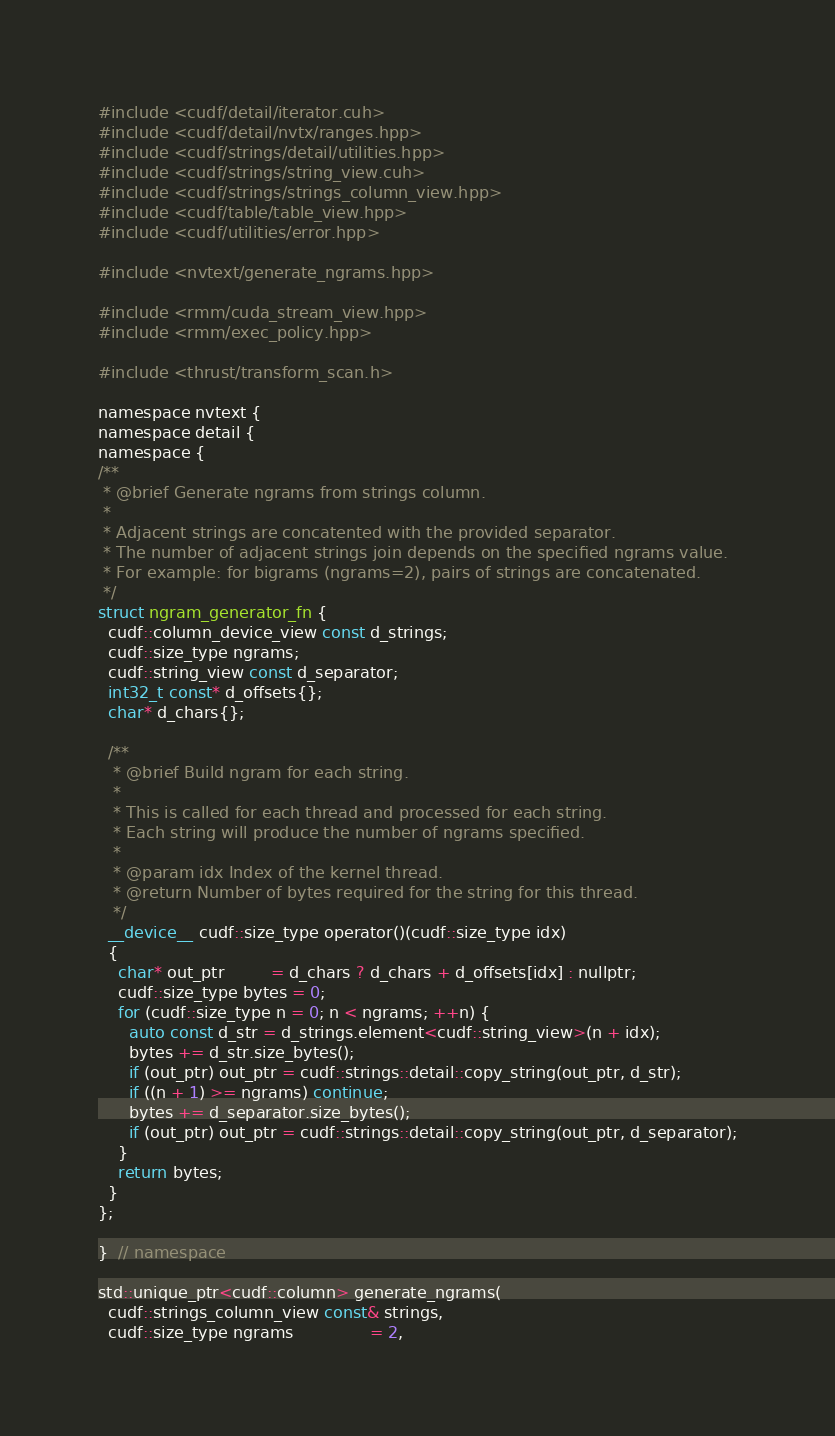<code> <loc_0><loc_0><loc_500><loc_500><_Cuda_>#include <cudf/detail/iterator.cuh>
#include <cudf/detail/nvtx/ranges.hpp>
#include <cudf/strings/detail/utilities.hpp>
#include <cudf/strings/string_view.cuh>
#include <cudf/strings/strings_column_view.hpp>
#include <cudf/table/table_view.hpp>
#include <cudf/utilities/error.hpp>

#include <nvtext/generate_ngrams.hpp>

#include <rmm/cuda_stream_view.hpp>
#include <rmm/exec_policy.hpp>

#include <thrust/transform_scan.h>

namespace nvtext {
namespace detail {
namespace {
/**
 * @brief Generate ngrams from strings column.
 *
 * Adjacent strings are concatented with the provided separator.
 * The number of adjacent strings join depends on the specified ngrams value.
 * For example: for bigrams (ngrams=2), pairs of strings are concatenated.
 */
struct ngram_generator_fn {
  cudf::column_device_view const d_strings;
  cudf::size_type ngrams;
  cudf::string_view const d_separator;
  int32_t const* d_offsets{};
  char* d_chars{};

  /**
   * @brief Build ngram for each string.
   *
   * This is called for each thread and processed for each string.
   * Each string will produce the number of ngrams specified.
   *
   * @param idx Index of the kernel thread.
   * @return Number of bytes required for the string for this thread.
   */
  __device__ cudf::size_type operator()(cudf::size_type idx)
  {
    char* out_ptr         = d_chars ? d_chars + d_offsets[idx] : nullptr;
    cudf::size_type bytes = 0;
    for (cudf::size_type n = 0; n < ngrams; ++n) {
      auto const d_str = d_strings.element<cudf::string_view>(n + idx);
      bytes += d_str.size_bytes();
      if (out_ptr) out_ptr = cudf::strings::detail::copy_string(out_ptr, d_str);
      if ((n + 1) >= ngrams) continue;
      bytes += d_separator.size_bytes();
      if (out_ptr) out_ptr = cudf::strings::detail::copy_string(out_ptr, d_separator);
    }
    return bytes;
  }
};

}  // namespace

std::unique_ptr<cudf::column> generate_ngrams(
  cudf::strings_column_view const& strings,
  cudf::size_type ngrams               = 2,</code> 